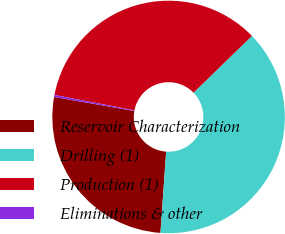Convert chart to OTSL. <chart><loc_0><loc_0><loc_500><loc_500><pie_chart><fcel>Reservoir Characterization<fcel>Drilling (1)<fcel>Production (1)<fcel>Eliminations & other<nl><fcel>26.64%<fcel>38.39%<fcel>34.69%<fcel>0.28%<nl></chart> 